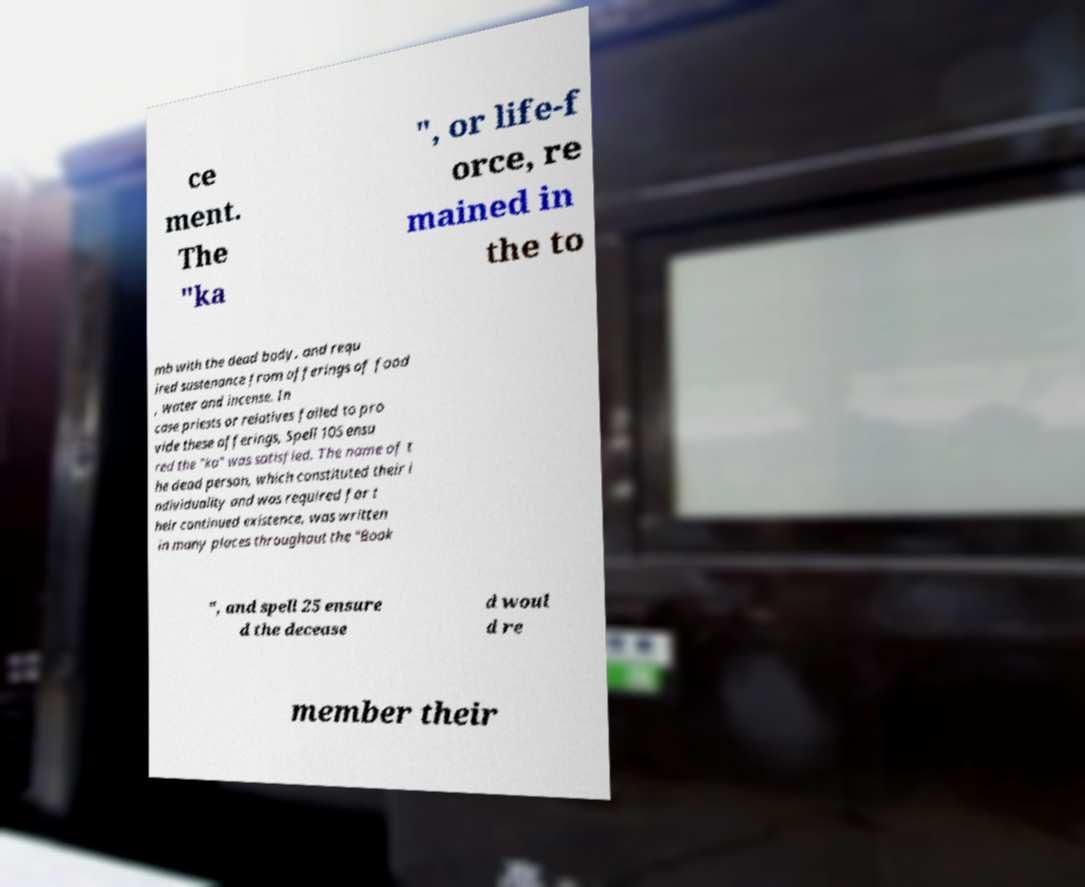Can you accurately transcribe the text from the provided image for me? ce ment. The "ka ", or life-f orce, re mained in the to mb with the dead body, and requ ired sustenance from offerings of food , water and incense. In case priests or relatives failed to pro vide these offerings, Spell 105 ensu red the "ka" was satisfied. The name of t he dead person, which constituted their i ndividuality and was required for t heir continued existence, was written in many places throughout the "Book ", and spell 25 ensure d the decease d woul d re member their 